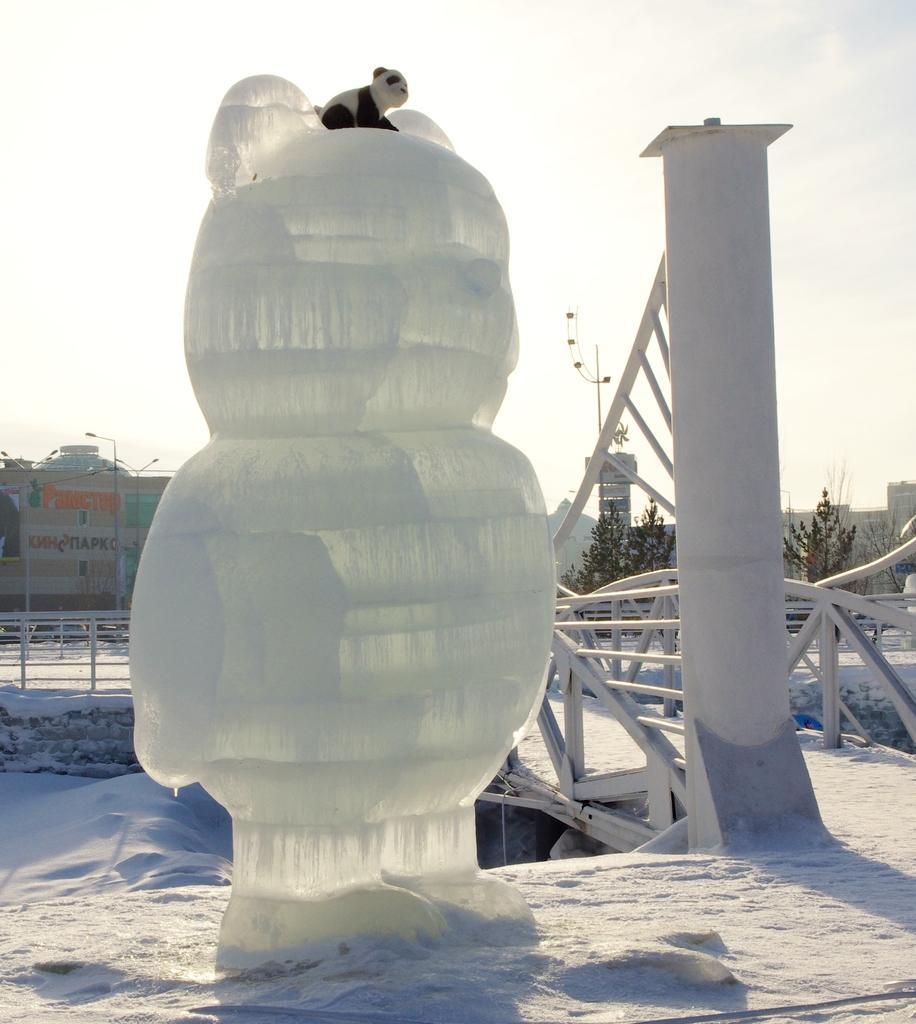How would you summarize this image in a sentence or two? In this image we can see a statue, pillar, railing, and an animal. In the background we can see buildings, trees, and sky. 